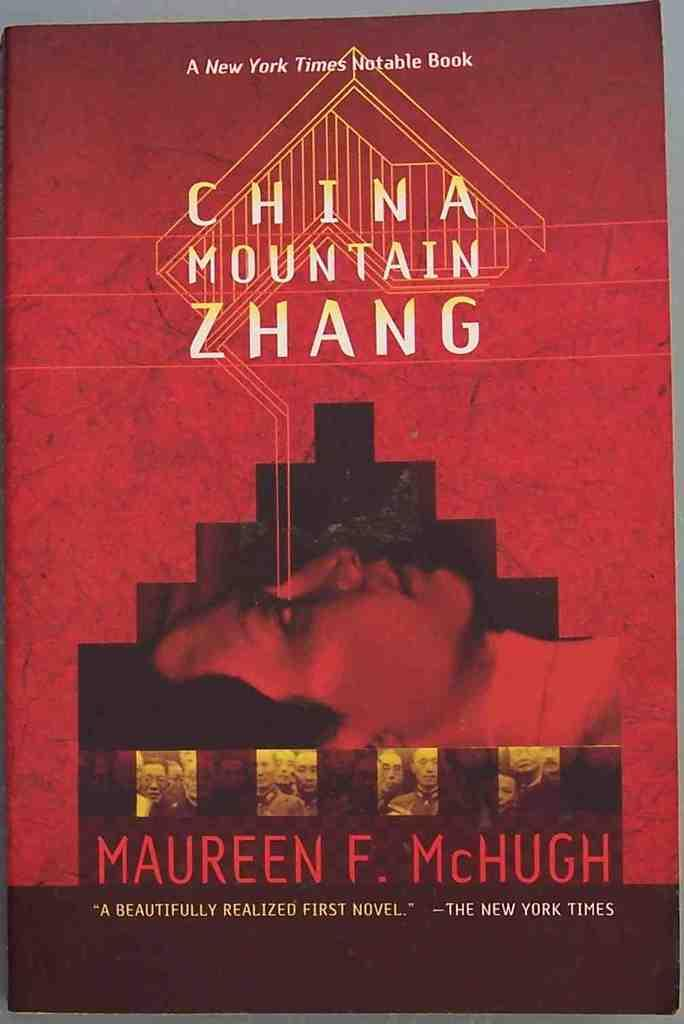<image>
Give a short and clear explanation of the subsequent image. Book cover titled China Mountain Zhang showing a man's face. 